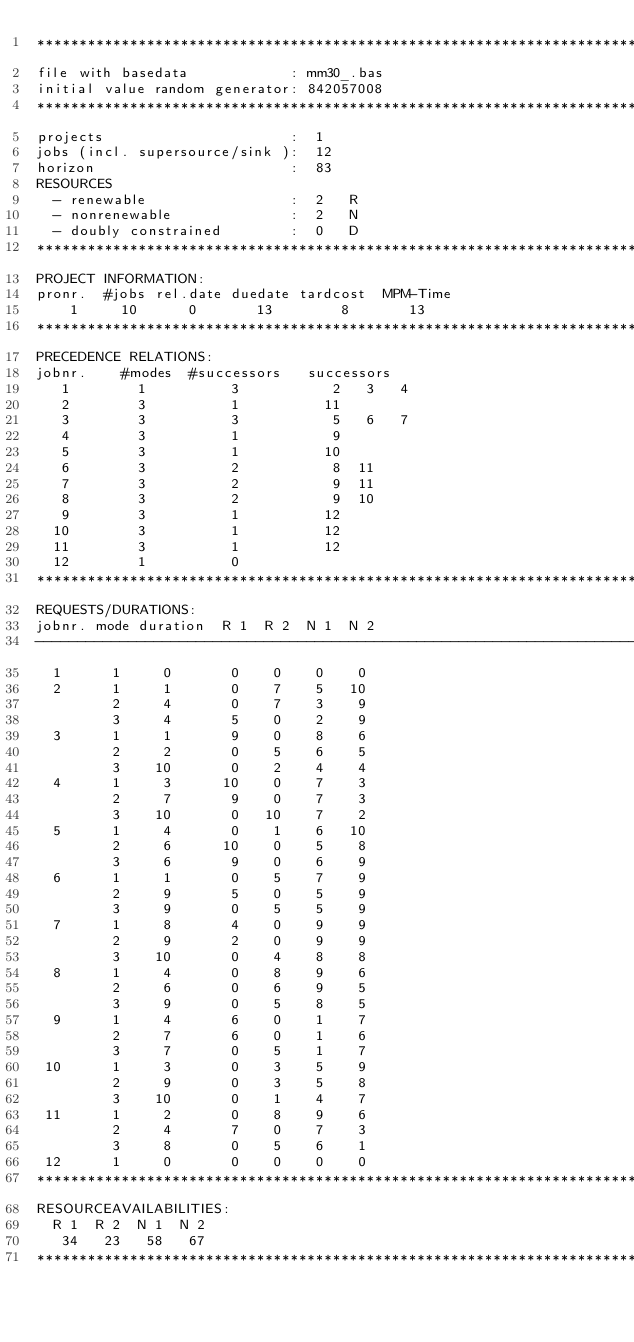<code> <loc_0><loc_0><loc_500><loc_500><_ObjectiveC_>************************************************************************
file with basedata            : mm30_.bas
initial value random generator: 842057008
************************************************************************
projects                      :  1
jobs (incl. supersource/sink ):  12
horizon                       :  83
RESOURCES
  - renewable                 :  2   R
  - nonrenewable              :  2   N
  - doubly constrained        :  0   D
************************************************************************
PROJECT INFORMATION:
pronr.  #jobs rel.date duedate tardcost  MPM-Time
    1     10      0       13        8       13
************************************************************************
PRECEDENCE RELATIONS:
jobnr.    #modes  #successors   successors
   1        1          3           2   3   4
   2        3          1          11
   3        3          3           5   6   7
   4        3          1           9
   5        3          1          10
   6        3          2           8  11
   7        3          2           9  11
   8        3          2           9  10
   9        3          1          12
  10        3          1          12
  11        3          1          12
  12        1          0        
************************************************************************
REQUESTS/DURATIONS:
jobnr. mode duration  R 1  R 2  N 1  N 2
------------------------------------------------------------------------
  1      1     0       0    0    0    0
  2      1     1       0    7    5   10
         2     4       0    7    3    9
         3     4       5    0    2    9
  3      1     1       9    0    8    6
         2     2       0    5    6    5
         3    10       0    2    4    4
  4      1     3      10    0    7    3
         2     7       9    0    7    3
         3    10       0   10    7    2
  5      1     4       0    1    6   10
         2     6      10    0    5    8
         3     6       9    0    6    9
  6      1     1       0    5    7    9
         2     9       5    0    5    9
         3     9       0    5    5    9
  7      1     8       4    0    9    9
         2     9       2    0    9    9
         3    10       0    4    8    8
  8      1     4       0    8    9    6
         2     6       0    6    9    5
         3     9       0    5    8    5
  9      1     4       6    0    1    7
         2     7       6    0    1    6
         3     7       0    5    1    7
 10      1     3       0    3    5    9
         2     9       0    3    5    8
         3    10       0    1    4    7
 11      1     2       0    8    9    6
         2     4       7    0    7    3
         3     8       0    5    6    1
 12      1     0       0    0    0    0
************************************************************************
RESOURCEAVAILABILITIES:
  R 1  R 2  N 1  N 2
   34   23   58   67
************************************************************************
</code> 